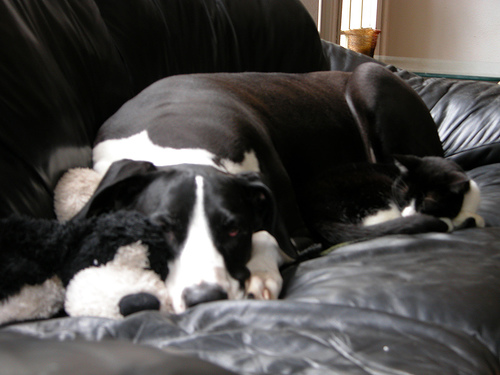The couch seems to be a favorite spot for these pets. What does that suggest about their environment? The fact that both the dog and cat have found a shared comfortable spot on the couch suggests that their environment is a shared, pet-friendly space where they feel safe and at ease to relax together. 